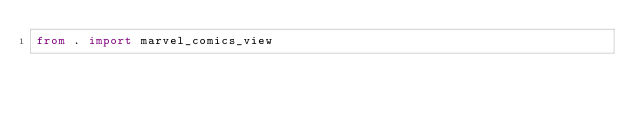Convert code to text. <code><loc_0><loc_0><loc_500><loc_500><_Python_>from . import marvel_comics_view
</code> 